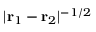<formula> <loc_0><loc_0><loc_500><loc_500>| { r } _ { 1 } - { r } _ { 2 } | ^ { - 1 / 2 }</formula> 